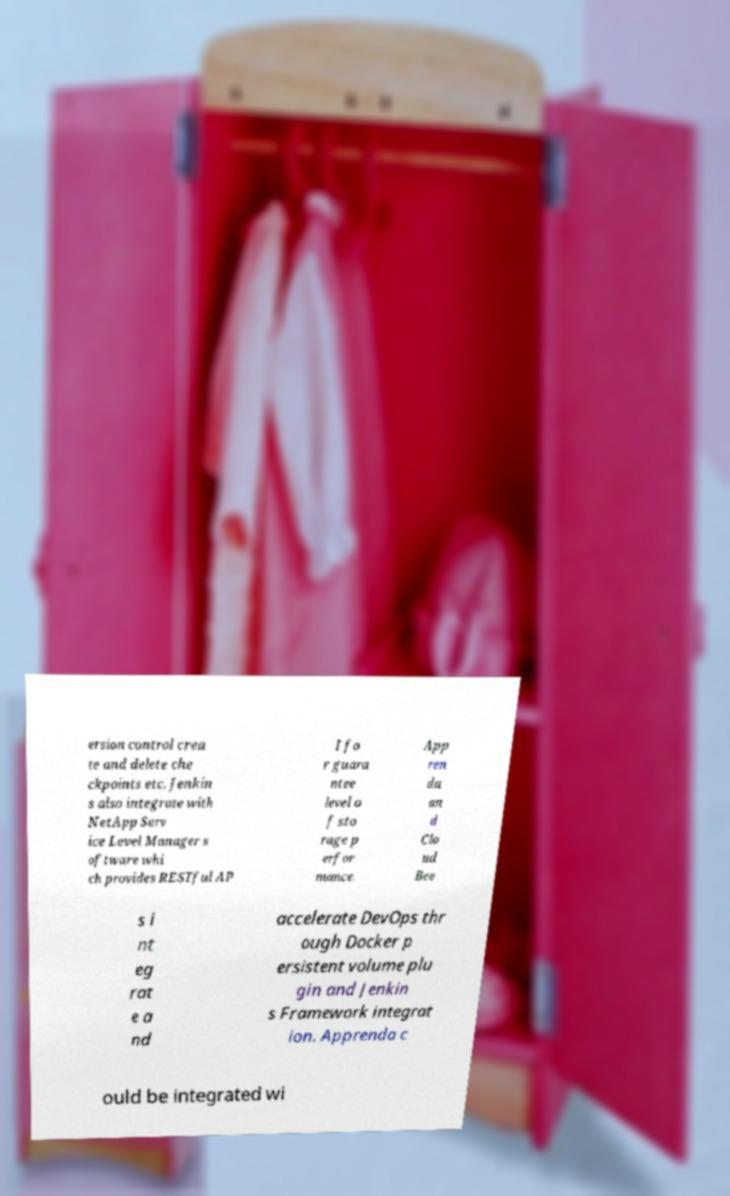Please read and relay the text visible in this image. What does it say? ersion control crea te and delete che ckpoints etc. Jenkin s also integrate with NetApp Serv ice Level Manager s oftware whi ch provides RESTful AP I fo r guara ntee level o f sto rage p erfor mance. App ren da an d Clo ud Bee s i nt eg rat e a nd accelerate DevOps thr ough Docker p ersistent volume plu gin and Jenkin s Framework integrat ion. Apprenda c ould be integrated wi 